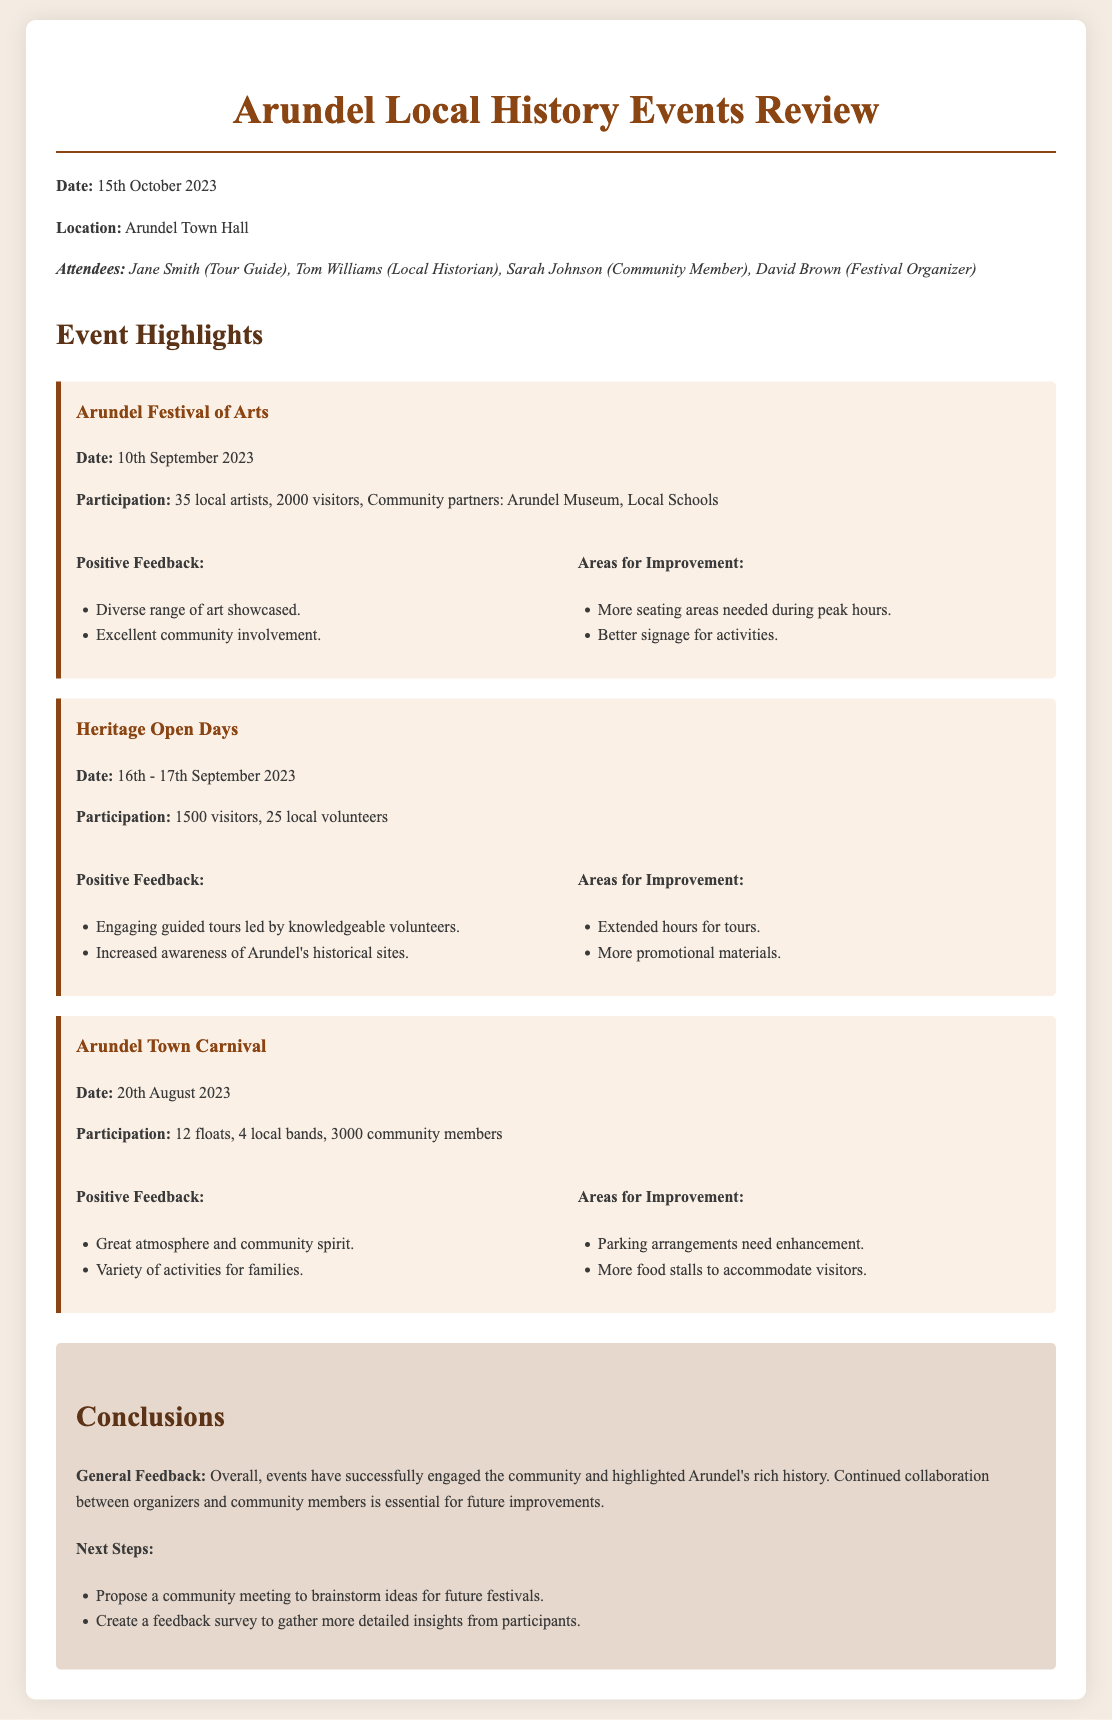What is the date of the meeting? The date of the meeting is clearly stated at the beginning of the document.
Answer: 15th October 2023 Who attended the meeting? The attendees are listed in the section identifying those present at the meeting.
Answer: Jane Smith, Tom Williams, Sarah Johnson, David Brown How many participants were at the Arundel Festival of Arts? The document specifies participation statistics for this event.
Answer: 2000 visitors What is the main feedback for the Heritage Open Days? The general feedback is summarized in the 'Positive Feedback' section for the event.
Answer: Engaging guided tours led by knowledgeable volunteers What improvement was suggested for the Arundel Town Carnival? Areas for improvement are specifically listed for each event.
Answer: Parking arrangements need enhancement What is highlighted as essential for future improvements? The conclusions section discusses the importance of collaboration for events.
Answer: Continued collaboration between organizers and community members What is the total number of floats in the Arundel Town Carnival? The participation details for the carnival include the number of floats.
Answer: 12 floats What did attendees appreciate about the Arts Festival? The positive feedback section outlines specific aspects appreciated by attendees.
Answer: Excellent community involvement What is the next step mentioned for future festivals? The conclusions section lists steps to be taken after the review meeting.
Answer: Propose a community meeting to brainstorm ideas for future festivals 